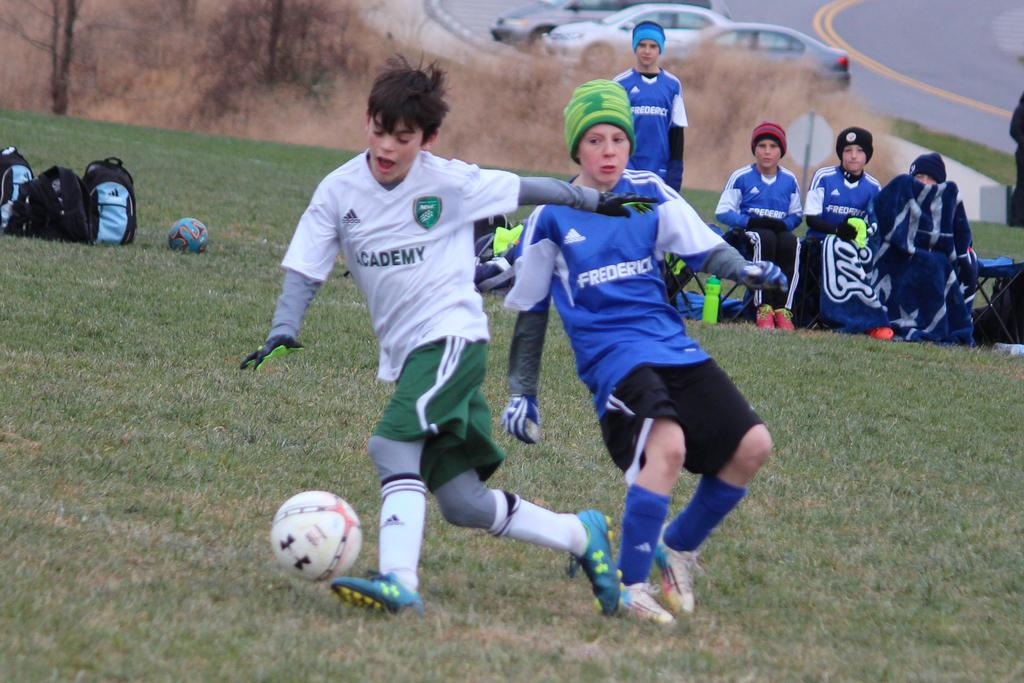<image>
Summarize the visual content of the image. A person in a Frederick jersey plays soccer with someone in in Academy jersey. 